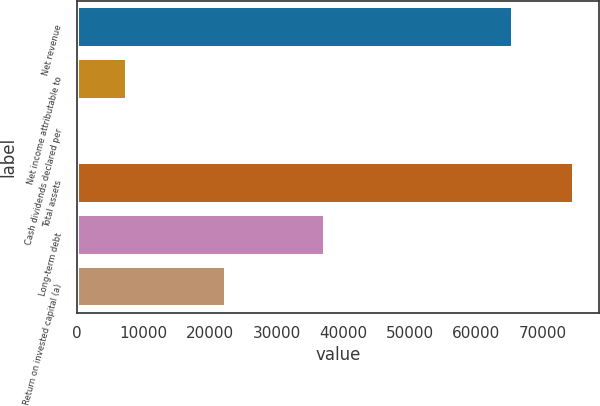Convert chart. <chart><loc_0><loc_0><loc_500><loc_500><bar_chart><fcel>Net revenue<fcel>Net income attributable to<fcel>Cash dividends declared per<fcel>Total assets<fcel>Long-term debt<fcel>Return on invested capital (a)<nl><fcel>65492<fcel>7465.72<fcel>2.13<fcel>74638<fcel>37320.1<fcel>22392.9<nl></chart> 